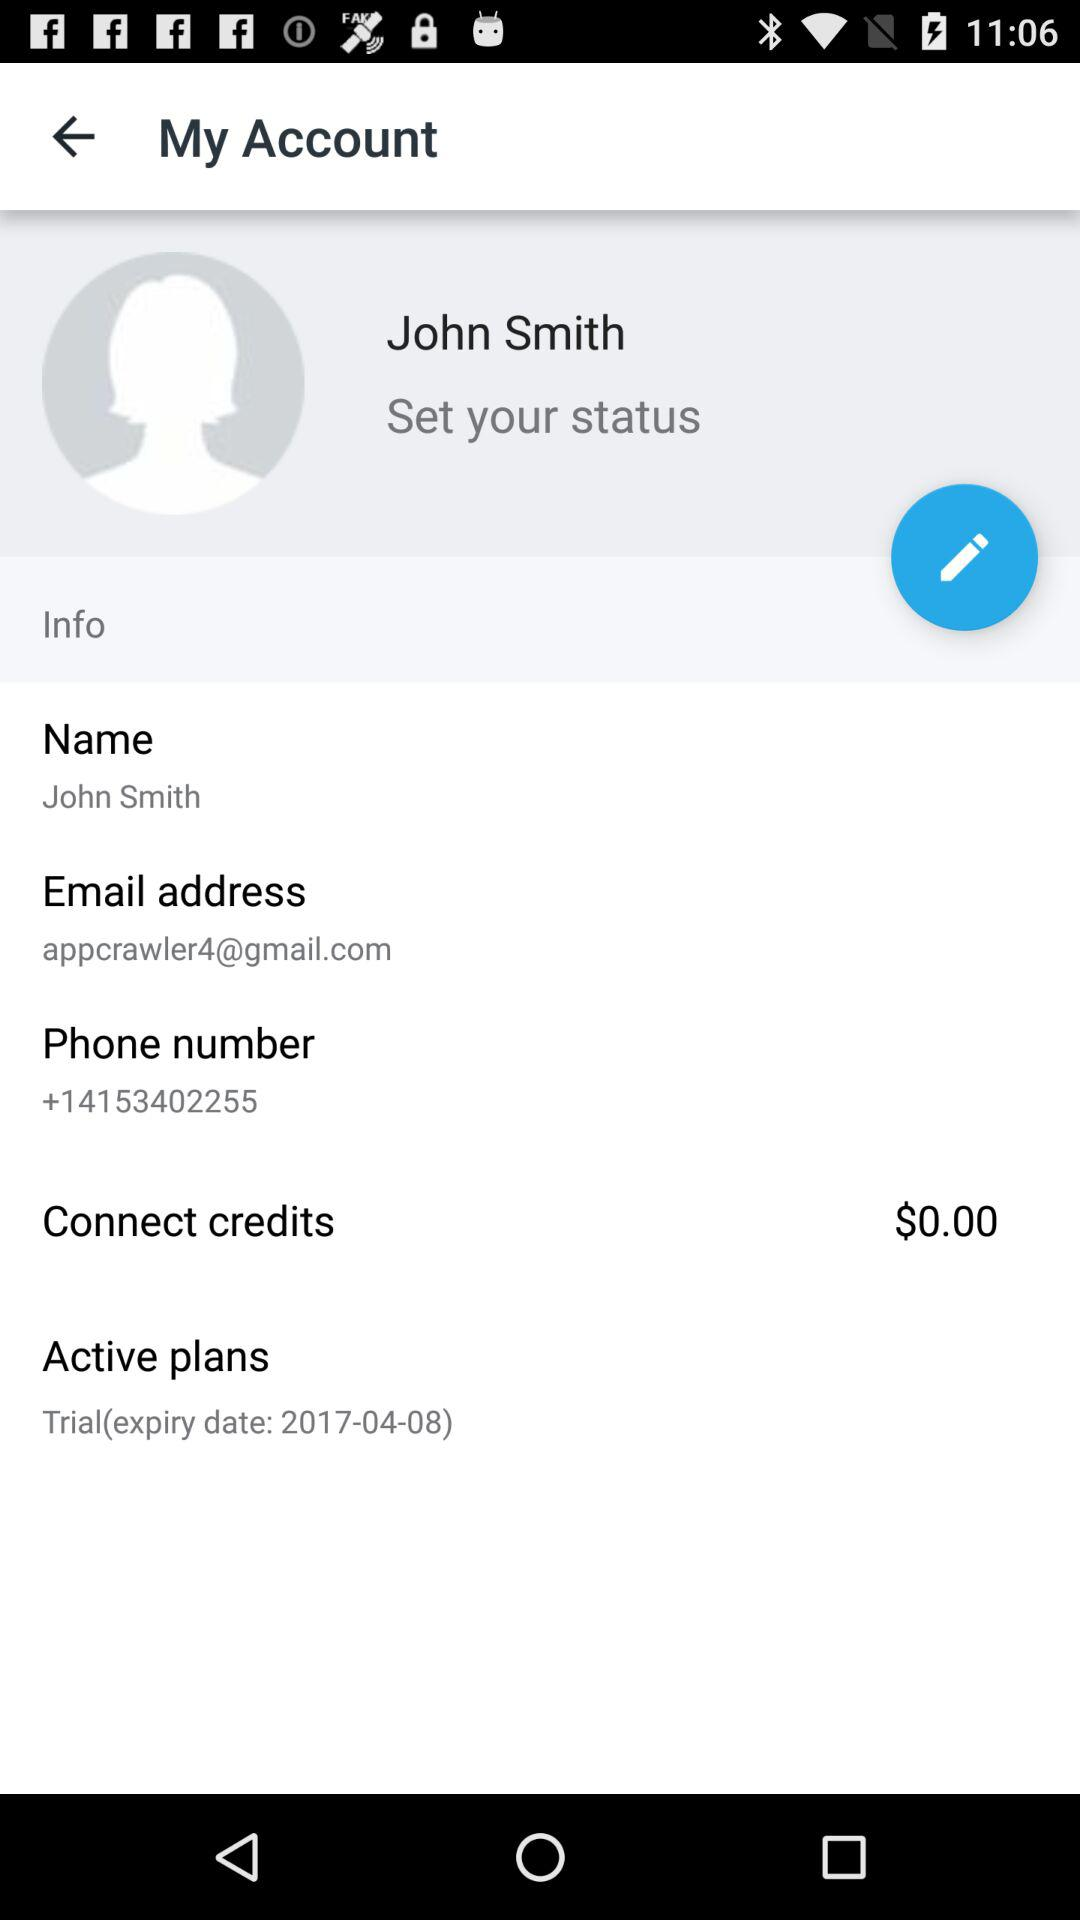What is the email address? The email address is appcrawler4@gmail.com. 